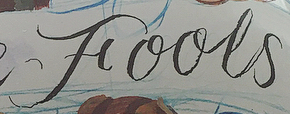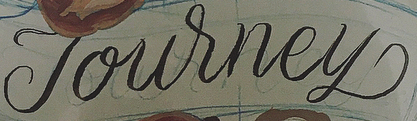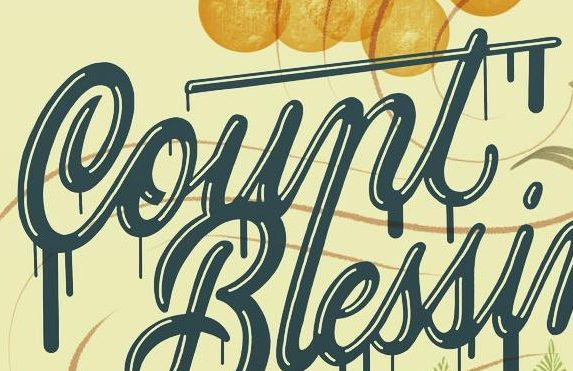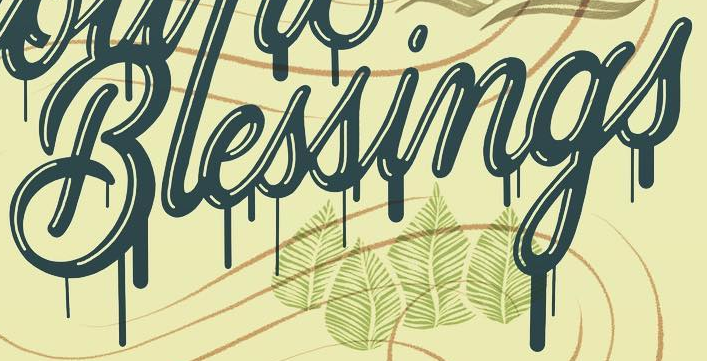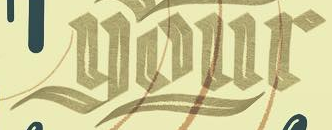Identify the words shown in these images in order, separated by a semicolon. Fools; Journey; Count; Blessings; your 